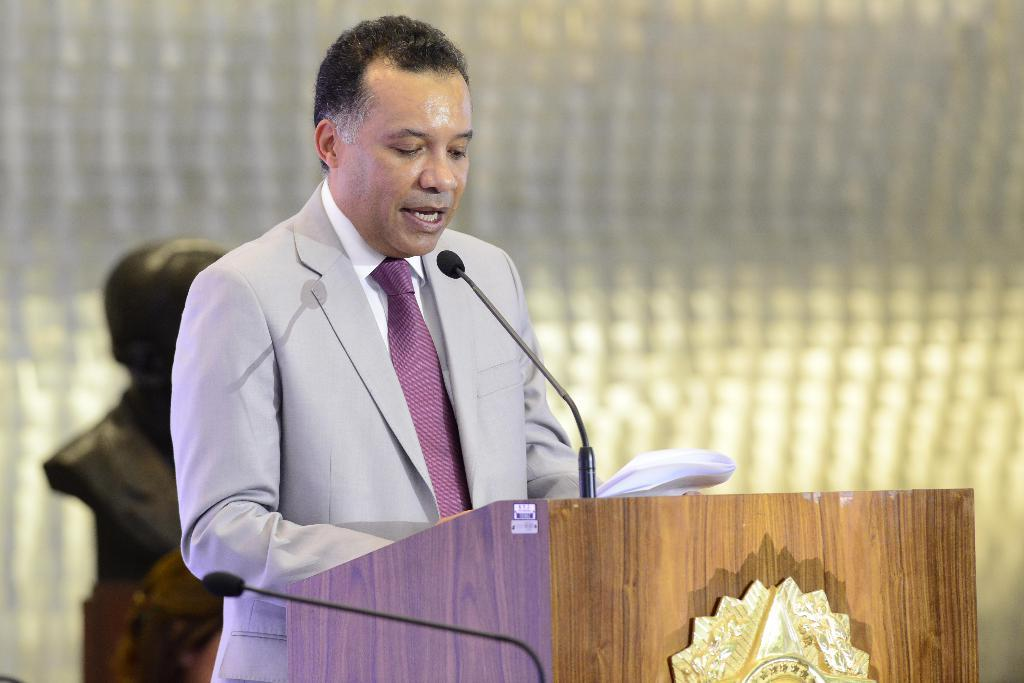Who is present in the image? There is a person in the image. What is the person wearing? The person is wearing a suit. Where is the person standing in relation to the desk? The person is standing in front of a desk. What objects can be seen on the desk? There is a mic and a paper on the desk. What is located behind the desk? There is a statue behind the desk. What type of gold property does the person own, as seen in the image? There is no mention of gold or property in the image; it only shows a person standing in front of a desk with a mic, paper, and statue. 